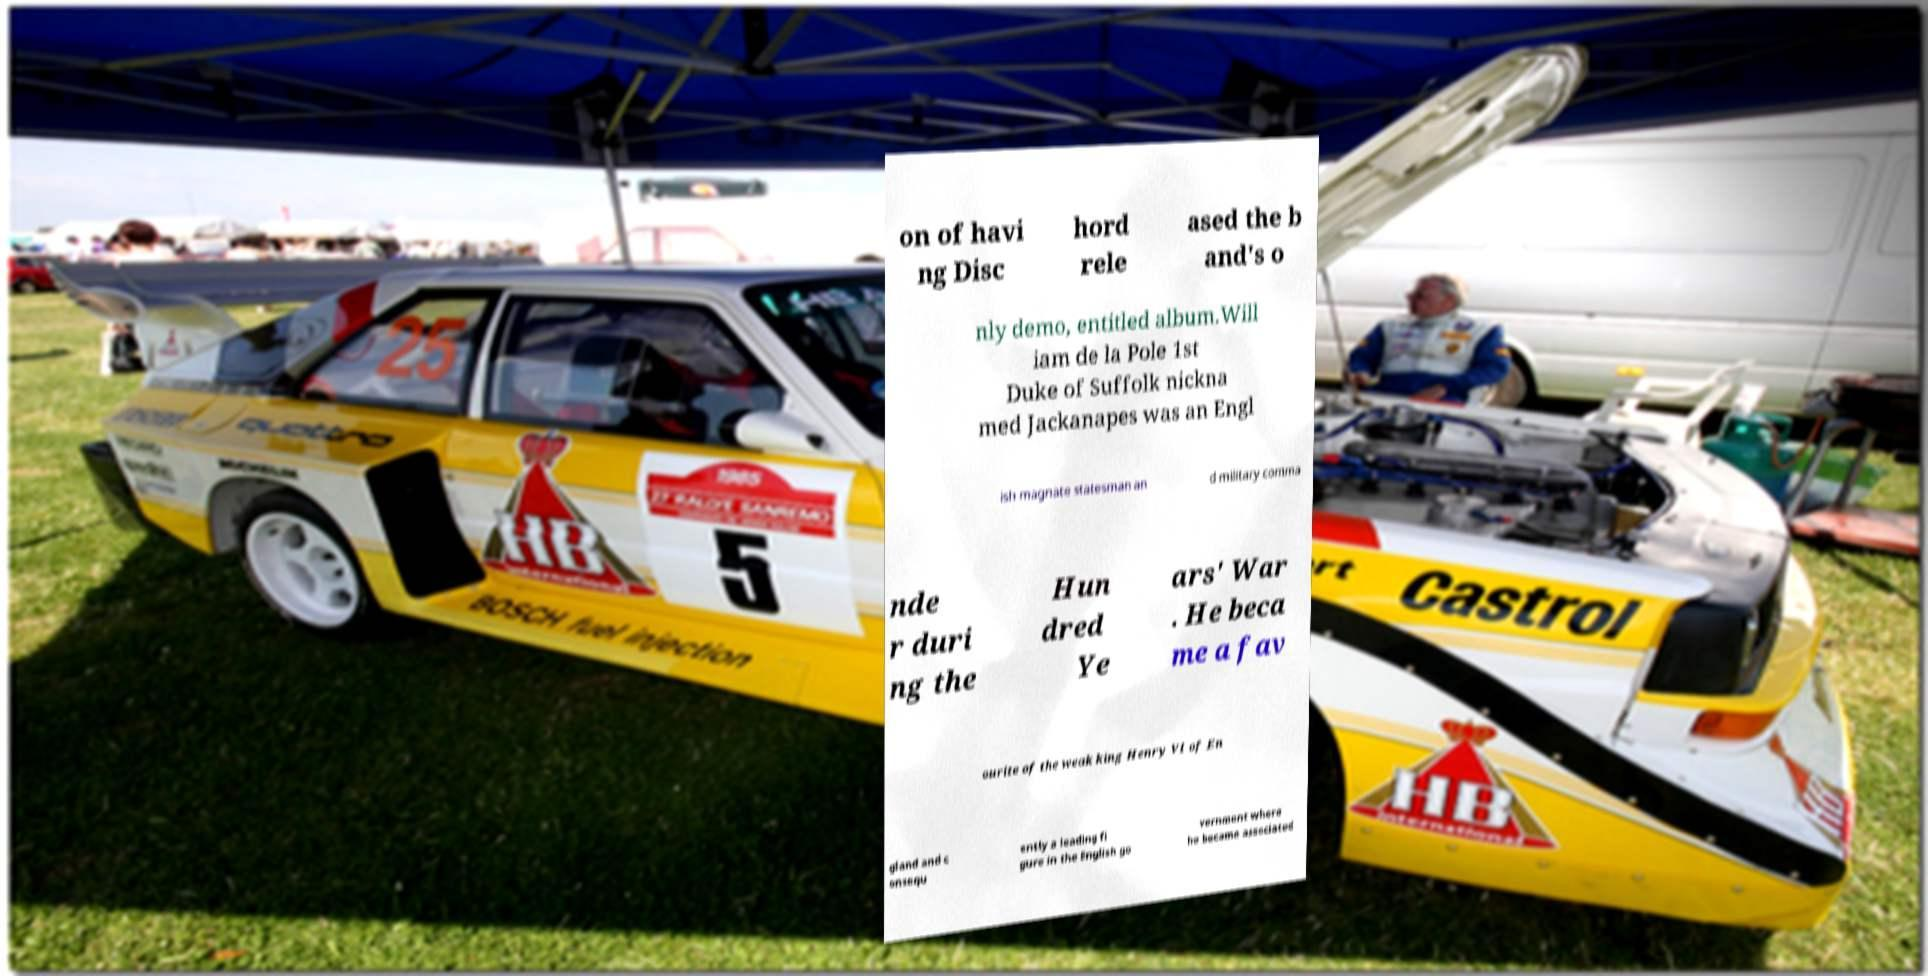I need the written content from this picture converted into text. Can you do that? on of havi ng Disc hord rele ased the b and's o nly demo, entitled album.Will iam de la Pole 1st Duke of Suffolk nickna med Jackanapes was an Engl ish magnate statesman an d military comma nde r duri ng the Hun dred Ye ars' War . He beca me a fav ourite of the weak king Henry VI of En gland and c onsequ ently a leading fi gure in the English go vernment where he became associated 